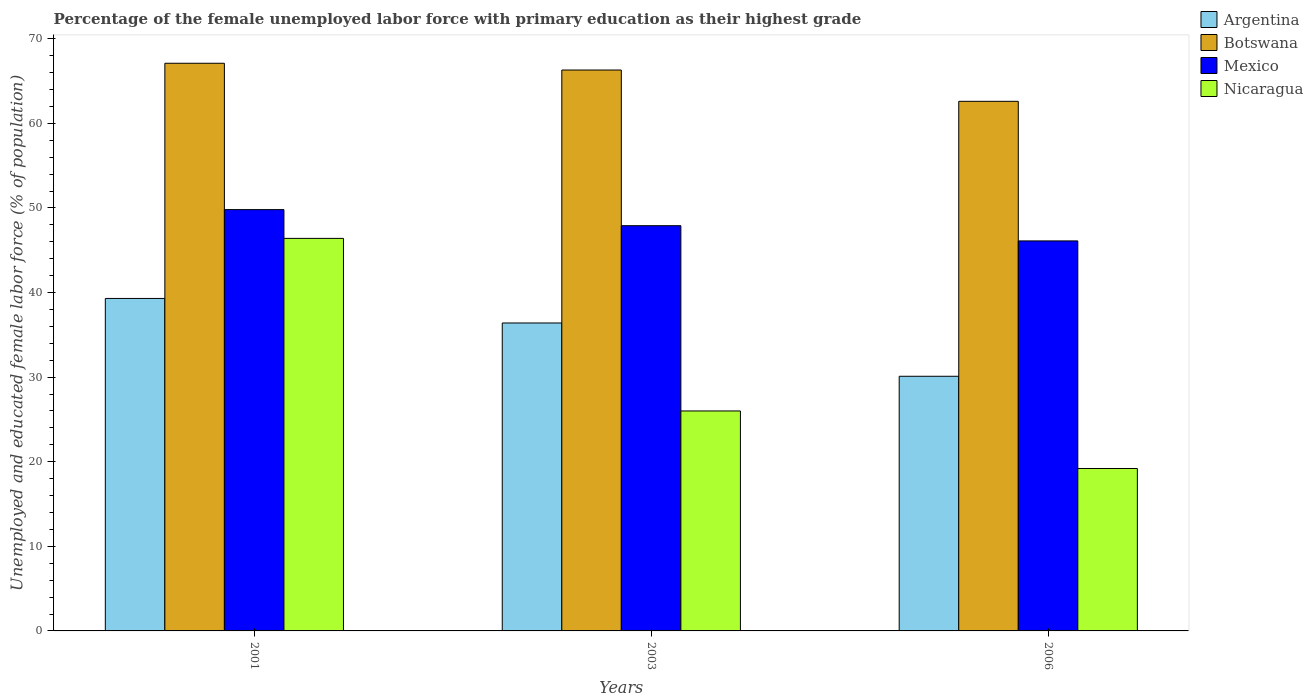How many different coloured bars are there?
Your answer should be compact. 4. Are the number of bars per tick equal to the number of legend labels?
Ensure brevity in your answer.  Yes. How many bars are there on the 2nd tick from the left?
Ensure brevity in your answer.  4. In how many cases, is the number of bars for a given year not equal to the number of legend labels?
Keep it short and to the point. 0. What is the percentage of the unemployed female labor force with primary education in Nicaragua in 2006?
Give a very brief answer. 19.2. Across all years, what is the maximum percentage of the unemployed female labor force with primary education in Botswana?
Your response must be concise. 67.1. Across all years, what is the minimum percentage of the unemployed female labor force with primary education in Argentina?
Keep it short and to the point. 30.1. In which year was the percentage of the unemployed female labor force with primary education in Botswana maximum?
Your answer should be very brief. 2001. In which year was the percentage of the unemployed female labor force with primary education in Mexico minimum?
Your response must be concise. 2006. What is the total percentage of the unemployed female labor force with primary education in Argentina in the graph?
Offer a very short reply. 105.8. What is the difference between the percentage of the unemployed female labor force with primary education in Nicaragua in 2001 and that in 2006?
Offer a very short reply. 27.2. What is the difference between the percentage of the unemployed female labor force with primary education in Mexico in 2003 and the percentage of the unemployed female labor force with primary education in Argentina in 2001?
Offer a terse response. 8.6. What is the average percentage of the unemployed female labor force with primary education in Botswana per year?
Your answer should be very brief. 65.33. In the year 2006, what is the difference between the percentage of the unemployed female labor force with primary education in Nicaragua and percentage of the unemployed female labor force with primary education in Argentina?
Your answer should be very brief. -10.9. What is the ratio of the percentage of the unemployed female labor force with primary education in Botswana in 2003 to that in 2006?
Provide a succinct answer. 1.06. What is the difference between the highest and the second highest percentage of the unemployed female labor force with primary education in Nicaragua?
Offer a terse response. 20.4. What is the difference between the highest and the lowest percentage of the unemployed female labor force with primary education in Nicaragua?
Your response must be concise. 27.2. In how many years, is the percentage of the unemployed female labor force with primary education in Botswana greater than the average percentage of the unemployed female labor force with primary education in Botswana taken over all years?
Your answer should be compact. 2. Is the sum of the percentage of the unemployed female labor force with primary education in Argentina in 2001 and 2006 greater than the maximum percentage of the unemployed female labor force with primary education in Nicaragua across all years?
Your answer should be compact. Yes. What does the 3rd bar from the left in 2001 represents?
Ensure brevity in your answer.  Mexico. What does the 1st bar from the right in 2003 represents?
Offer a very short reply. Nicaragua. Are all the bars in the graph horizontal?
Provide a succinct answer. No. How many years are there in the graph?
Offer a terse response. 3. What is the difference between two consecutive major ticks on the Y-axis?
Your answer should be compact. 10. Are the values on the major ticks of Y-axis written in scientific E-notation?
Provide a short and direct response. No. How many legend labels are there?
Give a very brief answer. 4. What is the title of the graph?
Offer a terse response. Percentage of the female unemployed labor force with primary education as their highest grade. Does "Swaziland" appear as one of the legend labels in the graph?
Your response must be concise. No. What is the label or title of the X-axis?
Provide a succinct answer. Years. What is the label or title of the Y-axis?
Your answer should be very brief. Unemployed and educated female labor force (% of population). What is the Unemployed and educated female labor force (% of population) of Argentina in 2001?
Keep it short and to the point. 39.3. What is the Unemployed and educated female labor force (% of population) of Botswana in 2001?
Provide a short and direct response. 67.1. What is the Unemployed and educated female labor force (% of population) of Mexico in 2001?
Your answer should be compact. 49.8. What is the Unemployed and educated female labor force (% of population) in Nicaragua in 2001?
Give a very brief answer. 46.4. What is the Unemployed and educated female labor force (% of population) of Argentina in 2003?
Your answer should be compact. 36.4. What is the Unemployed and educated female labor force (% of population) in Botswana in 2003?
Provide a short and direct response. 66.3. What is the Unemployed and educated female labor force (% of population) of Mexico in 2003?
Give a very brief answer. 47.9. What is the Unemployed and educated female labor force (% of population) in Nicaragua in 2003?
Offer a very short reply. 26. What is the Unemployed and educated female labor force (% of population) in Argentina in 2006?
Give a very brief answer. 30.1. What is the Unemployed and educated female labor force (% of population) in Botswana in 2006?
Ensure brevity in your answer.  62.6. What is the Unemployed and educated female labor force (% of population) of Mexico in 2006?
Ensure brevity in your answer.  46.1. What is the Unemployed and educated female labor force (% of population) of Nicaragua in 2006?
Provide a short and direct response. 19.2. Across all years, what is the maximum Unemployed and educated female labor force (% of population) in Argentina?
Provide a short and direct response. 39.3. Across all years, what is the maximum Unemployed and educated female labor force (% of population) in Botswana?
Your answer should be compact. 67.1. Across all years, what is the maximum Unemployed and educated female labor force (% of population) of Mexico?
Offer a terse response. 49.8. Across all years, what is the maximum Unemployed and educated female labor force (% of population) in Nicaragua?
Your response must be concise. 46.4. Across all years, what is the minimum Unemployed and educated female labor force (% of population) in Argentina?
Keep it short and to the point. 30.1. Across all years, what is the minimum Unemployed and educated female labor force (% of population) in Botswana?
Ensure brevity in your answer.  62.6. Across all years, what is the minimum Unemployed and educated female labor force (% of population) of Mexico?
Your answer should be very brief. 46.1. Across all years, what is the minimum Unemployed and educated female labor force (% of population) in Nicaragua?
Offer a very short reply. 19.2. What is the total Unemployed and educated female labor force (% of population) of Argentina in the graph?
Keep it short and to the point. 105.8. What is the total Unemployed and educated female labor force (% of population) in Botswana in the graph?
Offer a very short reply. 196. What is the total Unemployed and educated female labor force (% of population) in Mexico in the graph?
Make the answer very short. 143.8. What is the total Unemployed and educated female labor force (% of population) of Nicaragua in the graph?
Your response must be concise. 91.6. What is the difference between the Unemployed and educated female labor force (% of population) of Argentina in 2001 and that in 2003?
Give a very brief answer. 2.9. What is the difference between the Unemployed and educated female labor force (% of population) of Nicaragua in 2001 and that in 2003?
Provide a short and direct response. 20.4. What is the difference between the Unemployed and educated female labor force (% of population) of Argentina in 2001 and that in 2006?
Make the answer very short. 9.2. What is the difference between the Unemployed and educated female labor force (% of population) in Botswana in 2001 and that in 2006?
Offer a very short reply. 4.5. What is the difference between the Unemployed and educated female labor force (% of population) of Nicaragua in 2001 and that in 2006?
Make the answer very short. 27.2. What is the difference between the Unemployed and educated female labor force (% of population) in Mexico in 2003 and that in 2006?
Offer a very short reply. 1.8. What is the difference between the Unemployed and educated female labor force (% of population) of Argentina in 2001 and the Unemployed and educated female labor force (% of population) of Mexico in 2003?
Provide a short and direct response. -8.6. What is the difference between the Unemployed and educated female labor force (% of population) in Argentina in 2001 and the Unemployed and educated female labor force (% of population) in Nicaragua in 2003?
Offer a very short reply. 13.3. What is the difference between the Unemployed and educated female labor force (% of population) in Botswana in 2001 and the Unemployed and educated female labor force (% of population) in Nicaragua in 2003?
Ensure brevity in your answer.  41.1. What is the difference between the Unemployed and educated female labor force (% of population) of Mexico in 2001 and the Unemployed and educated female labor force (% of population) of Nicaragua in 2003?
Ensure brevity in your answer.  23.8. What is the difference between the Unemployed and educated female labor force (% of population) in Argentina in 2001 and the Unemployed and educated female labor force (% of population) in Botswana in 2006?
Ensure brevity in your answer.  -23.3. What is the difference between the Unemployed and educated female labor force (% of population) of Argentina in 2001 and the Unemployed and educated female labor force (% of population) of Nicaragua in 2006?
Your response must be concise. 20.1. What is the difference between the Unemployed and educated female labor force (% of population) in Botswana in 2001 and the Unemployed and educated female labor force (% of population) in Mexico in 2006?
Offer a terse response. 21. What is the difference between the Unemployed and educated female labor force (% of population) in Botswana in 2001 and the Unemployed and educated female labor force (% of population) in Nicaragua in 2006?
Offer a terse response. 47.9. What is the difference between the Unemployed and educated female labor force (% of population) in Mexico in 2001 and the Unemployed and educated female labor force (% of population) in Nicaragua in 2006?
Ensure brevity in your answer.  30.6. What is the difference between the Unemployed and educated female labor force (% of population) in Argentina in 2003 and the Unemployed and educated female labor force (% of population) in Botswana in 2006?
Your response must be concise. -26.2. What is the difference between the Unemployed and educated female labor force (% of population) of Argentina in 2003 and the Unemployed and educated female labor force (% of population) of Mexico in 2006?
Provide a succinct answer. -9.7. What is the difference between the Unemployed and educated female labor force (% of population) in Argentina in 2003 and the Unemployed and educated female labor force (% of population) in Nicaragua in 2006?
Your answer should be very brief. 17.2. What is the difference between the Unemployed and educated female labor force (% of population) of Botswana in 2003 and the Unemployed and educated female labor force (% of population) of Mexico in 2006?
Offer a very short reply. 20.2. What is the difference between the Unemployed and educated female labor force (% of population) of Botswana in 2003 and the Unemployed and educated female labor force (% of population) of Nicaragua in 2006?
Your response must be concise. 47.1. What is the difference between the Unemployed and educated female labor force (% of population) of Mexico in 2003 and the Unemployed and educated female labor force (% of population) of Nicaragua in 2006?
Provide a short and direct response. 28.7. What is the average Unemployed and educated female labor force (% of population) in Argentina per year?
Give a very brief answer. 35.27. What is the average Unemployed and educated female labor force (% of population) of Botswana per year?
Offer a terse response. 65.33. What is the average Unemployed and educated female labor force (% of population) of Mexico per year?
Ensure brevity in your answer.  47.93. What is the average Unemployed and educated female labor force (% of population) in Nicaragua per year?
Offer a terse response. 30.53. In the year 2001, what is the difference between the Unemployed and educated female labor force (% of population) of Argentina and Unemployed and educated female labor force (% of population) of Botswana?
Your response must be concise. -27.8. In the year 2001, what is the difference between the Unemployed and educated female labor force (% of population) in Argentina and Unemployed and educated female labor force (% of population) in Nicaragua?
Provide a succinct answer. -7.1. In the year 2001, what is the difference between the Unemployed and educated female labor force (% of population) of Botswana and Unemployed and educated female labor force (% of population) of Mexico?
Make the answer very short. 17.3. In the year 2001, what is the difference between the Unemployed and educated female labor force (% of population) of Botswana and Unemployed and educated female labor force (% of population) of Nicaragua?
Provide a succinct answer. 20.7. In the year 2003, what is the difference between the Unemployed and educated female labor force (% of population) of Argentina and Unemployed and educated female labor force (% of population) of Botswana?
Make the answer very short. -29.9. In the year 2003, what is the difference between the Unemployed and educated female labor force (% of population) of Argentina and Unemployed and educated female labor force (% of population) of Mexico?
Ensure brevity in your answer.  -11.5. In the year 2003, what is the difference between the Unemployed and educated female labor force (% of population) of Botswana and Unemployed and educated female labor force (% of population) of Mexico?
Provide a short and direct response. 18.4. In the year 2003, what is the difference between the Unemployed and educated female labor force (% of population) in Botswana and Unemployed and educated female labor force (% of population) in Nicaragua?
Provide a short and direct response. 40.3. In the year 2003, what is the difference between the Unemployed and educated female labor force (% of population) in Mexico and Unemployed and educated female labor force (% of population) in Nicaragua?
Offer a terse response. 21.9. In the year 2006, what is the difference between the Unemployed and educated female labor force (% of population) in Argentina and Unemployed and educated female labor force (% of population) in Botswana?
Keep it short and to the point. -32.5. In the year 2006, what is the difference between the Unemployed and educated female labor force (% of population) of Argentina and Unemployed and educated female labor force (% of population) of Mexico?
Your answer should be very brief. -16. In the year 2006, what is the difference between the Unemployed and educated female labor force (% of population) of Botswana and Unemployed and educated female labor force (% of population) of Mexico?
Your response must be concise. 16.5. In the year 2006, what is the difference between the Unemployed and educated female labor force (% of population) in Botswana and Unemployed and educated female labor force (% of population) in Nicaragua?
Your answer should be compact. 43.4. In the year 2006, what is the difference between the Unemployed and educated female labor force (% of population) in Mexico and Unemployed and educated female labor force (% of population) in Nicaragua?
Your response must be concise. 26.9. What is the ratio of the Unemployed and educated female labor force (% of population) in Argentina in 2001 to that in 2003?
Make the answer very short. 1.08. What is the ratio of the Unemployed and educated female labor force (% of population) of Botswana in 2001 to that in 2003?
Your answer should be compact. 1.01. What is the ratio of the Unemployed and educated female labor force (% of population) of Mexico in 2001 to that in 2003?
Your response must be concise. 1.04. What is the ratio of the Unemployed and educated female labor force (% of population) of Nicaragua in 2001 to that in 2003?
Your answer should be very brief. 1.78. What is the ratio of the Unemployed and educated female labor force (% of population) in Argentina in 2001 to that in 2006?
Ensure brevity in your answer.  1.31. What is the ratio of the Unemployed and educated female labor force (% of population) in Botswana in 2001 to that in 2006?
Your response must be concise. 1.07. What is the ratio of the Unemployed and educated female labor force (% of population) in Mexico in 2001 to that in 2006?
Your answer should be very brief. 1.08. What is the ratio of the Unemployed and educated female labor force (% of population) in Nicaragua in 2001 to that in 2006?
Ensure brevity in your answer.  2.42. What is the ratio of the Unemployed and educated female labor force (% of population) of Argentina in 2003 to that in 2006?
Provide a succinct answer. 1.21. What is the ratio of the Unemployed and educated female labor force (% of population) of Botswana in 2003 to that in 2006?
Keep it short and to the point. 1.06. What is the ratio of the Unemployed and educated female labor force (% of population) of Mexico in 2003 to that in 2006?
Provide a succinct answer. 1.04. What is the ratio of the Unemployed and educated female labor force (% of population) in Nicaragua in 2003 to that in 2006?
Your answer should be compact. 1.35. What is the difference between the highest and the second highest Unemployed and educated female labor force (% of population) in Argentina?
Your answer should be compact. 2.9. What is the difference between the highest and the second highest Unemployed and educated female labor force (% of population) of Botswana?
Ensure brevity in your answer.  0.8. What is the difference between the highest and the second highest Unemployed and educated female labor force (% of population) of Mexico?
Offer a very short reply. 1.9. What is the difference between the highest and the second highest Unemployed and educated female labor force (% of population) in Nicaragua?
Ensure brevity in your answer.  20.4. What is the difference between the highest and the lowest Unemployed and educated female labor force (% of population) in Argentina?
Offer a terse response. 9.2. What is the difference between the highest and the lowest Unemployed and educated female labor force (% of population) in Botswana?
Your response must be concise. 4.5. What is the difference between the highest and the lowest Unemployed and educated female labor force (% of population) in Mexico?
Keep it short and to the point. 3.7. What is the difference between the highest and the lowest Unemployed and educated female labor force (% of population) in Nicaragua?
Keep it short and to the point. 27.2. 